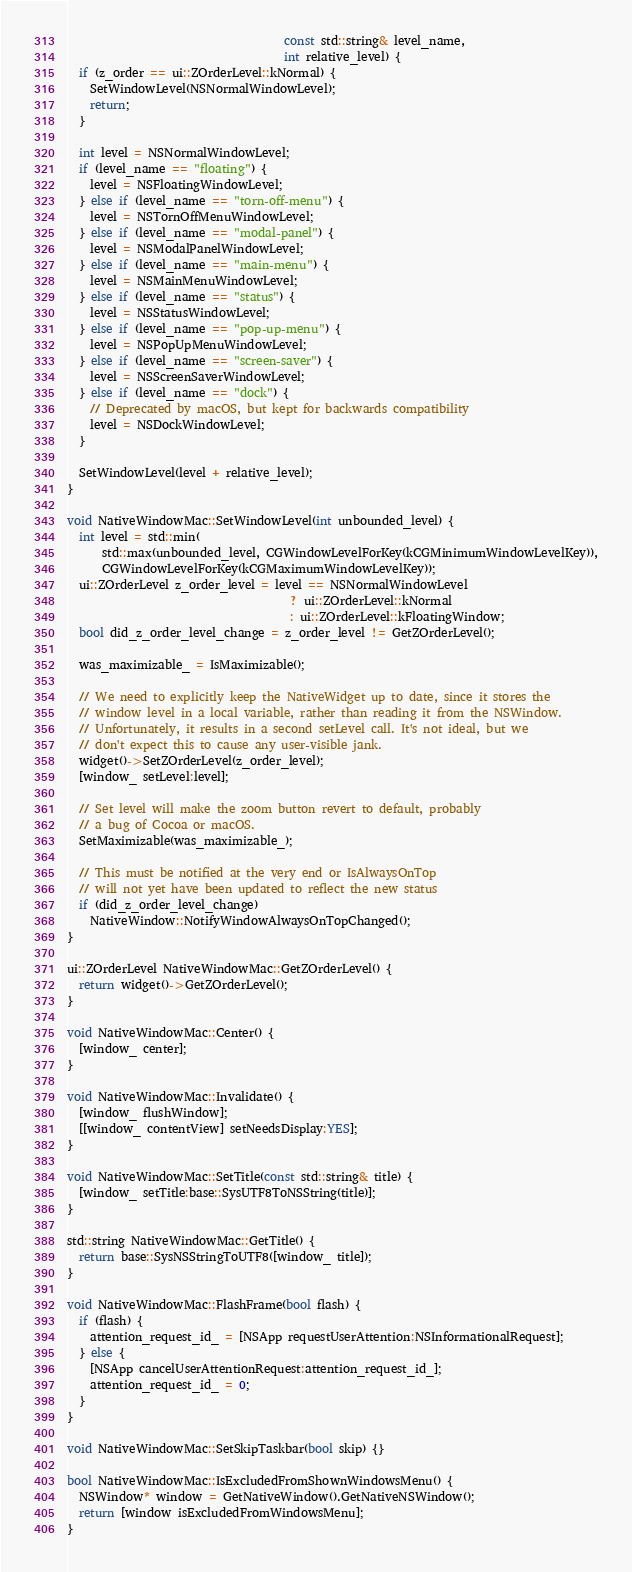Convert code to text. <code><loc_0><loc_0><loc_500><loc_500><_ObjectiveC_>                                     const std::string& level_name,
                                     int relative_level) {
  if (z_order == ui::ZOrderLevel::kNormal) {
    SetWindowLevel(NSNormalWindowLevel);
    return;
  }

  int level = NSNormalWindowLevel;
  if (level_name == "floating") {
    level = NSFloatingWindowLevel;
  } else if (level_name == "torn-off-menu") {
    level = NSTornOffMenuWindowLevel;
  } else if (level_name == "modal-panel") {
    level = NSModalPanelWindowLevel;
  } else if (level_name == "main-menu") {
    level = NSMainMenuWindowLevel;
  } else if (level_name == "status") {
    level = NSStatusWindowLevel;
  } else if (level_name == "pop-up-menu") {
    level = NSPopUpMenuWindowLevel;
  } else if (level_name == "screen-saver") {
    level = NSScreenSaverWindowLevel;
  } else if (level_name == "dock") {
    // Deprecated by macOS, but kept for backwards compatibility
    level = NSDockWindowLevel;
  }

  SetWindowLevel(level + relative_level);
}

void NativeWindowMac::SetWindowLevel(int unbounded_level) {
  int level = std::min(
      std::max(unbounded_level, CGWindowLevelForKey(kCGMinimumWindowLevelKey)),
      CGWindowLevelForKey(kCGMaximumWindowLevelKey));
  ui::ZOrderLevel z_order_level = level == NSNormalWindowLevel
                                      ? ui::ZOrderLevel::kNormal
                                      : ui::ZOrderLevel::kFloatingWindow;
  bool did_z_order_level_change = z_order_level != GetZOrderLevel();

  was_maximizable_ = IsMaximizable();

  // We need to explicitly keep the NativeWidget up to date, since it stores the
  // window level in a local variable, rather than reading it from the NSWindow.
  // Unfortunately, it results in a second setLevel call. It's not ideal, but we
  // don't expect this to cause any user-visible jank.
  widget()->SetZOrderLevel(z_order_level);
  [window_ setLevel:level];

  // Set level will make the zoom button revert to default, probably
  // a bug of Cocoa or macOS.
  SetMaximizable(was_maximizable_);

  // This must be notified at the very end or IsAlwaysOnTop
  // will not yet have been updated to reflect the new status
  if (did_z_order_level_change)
    NativeWindow::NotifyWindowAlwaysOnTopChanged();
}

ui::ZOrderLevel NativeWindowMac::GetZOrderLevel() {
  return widget()->GetZOrderLevel();
}

void NativeWindowMac::Center() {
  [window_ center];
}

void NativeWindowMac::Invalidate() {
  [window_ flushWindow];
  [[window_ contentView] setNeedsDisplay:YES];
}

void NativeWindowMac::SetTitle(const std::string& title) {
  [window_ setTitle:base::SysUTF8ToNSString(title)];
}

std::string NativeWindowMac::GetTitle() {
  return base::SysNSStringToUTF8([window_ title]);
}

void NativeWindowMac::FlashFrame(bool flash) {
  if (flash) {
    attention_request_id_ = [NSApp requestUserAttention:NSInformationalRequest];
  } else {
    [NSApp cancelUserAttentionRequest:attention_request_id_];
    attention_request_id_ = 0;
  }
}

void NativeWindowMac::SetSkipTaskbar(bool skip) {}

bool NativeWindowMac::IsExcludedFromShownWindowsMenu() {
  NSWindow* window = GetNativeWindow().GetNativeNSWindow();
  return [window isExcludedFromWindowsMenu];
}
</code> 